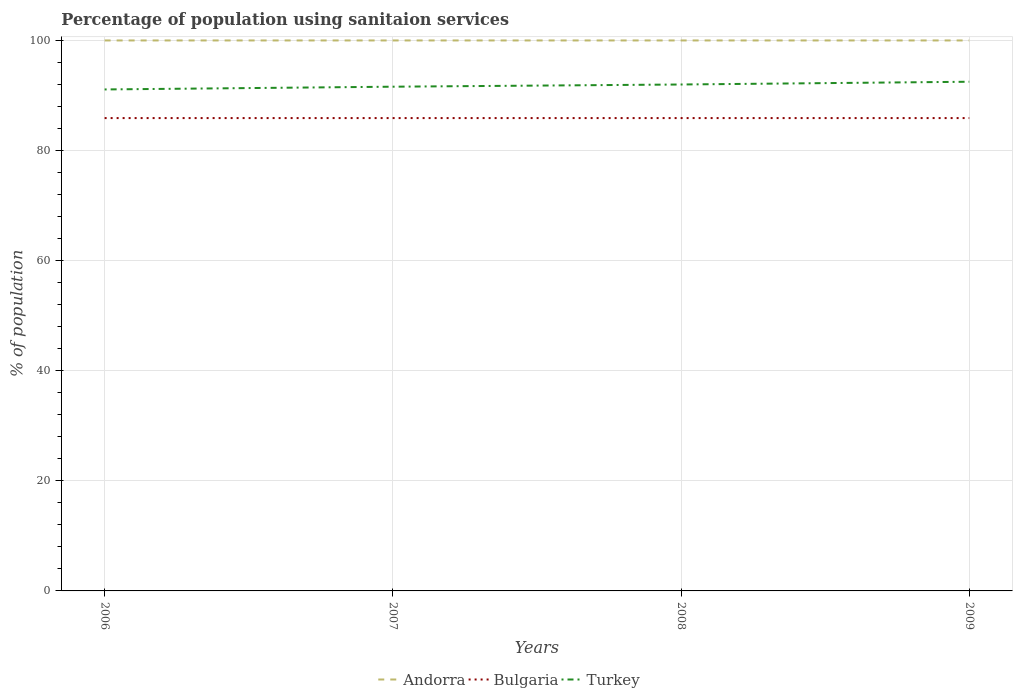How many different coloured lines are there?
Provide a succinct answer. 3. Across all years, what is the maximum percentage of population using sanitaion services in Turkey?
Offer a terse response. 91.1. In which year was the percentage of population using sanitaion services in Andorra maximum?
Your response must be concise. 2006. What is the total percentage of population using sanitaion services in Turkey in the graph?
Keep it short and to the point. -1.4. What is the difference between the highest and the second highest percentage of population using sanitaion services in Turkey?
Make the answer very short. 1.4. Is the percentage of population using sanitaion services in Turkey strictly greater than the percentage of population using sanitaion services in Bulgaria over the years?
Offer a terse response. No. How many lines are there?
Your answer should be very brief. 3. How many years are there in the graph?
Provide a succinct answer. 4. What is the difference between two consecutive major ticks on the Y-axis?
Ensure brevity in your answer.  20. What is the title of the graph?
Offer a terse response. Percentage of population using sanitaion services. What is the label or title of the X-axis?
Your answer should be compact. Years. What is the label or title of the Y-axis?
Your answer should be very brief. % of population. What is the % of population in Andorra in 2006?
Offer a terse response. 100. What is the % of population of Bulgaria in 2006?
Provide a succinct answer. 85.9. What is the % of population in Turkey in 2006?
Ensure brevity in your answer.  91.1. What is the % of population in Andorra in 2007?
Ensure brevity in your answer.  100. What is the % of population of Bulgaria in 2007?
Your response must be concise. 85.9. What is the % of population of Turkey in 2007?
Your answer should be very brief. 91.6. What is the % of population in Andorra in 2008?
Offer a very short reply. 100. What is the % of population of Bulgaria in 2008?
Make the answer very short. 85.9. What is the % of population in Turkey in 2008?
Your answer should be very brief. 92. What is the % of population in Andorra in 2009?
Ensure brevity in your answer.  100. What is the % of population in Bulgaria in 2009?
Your answer should be very brief. 85.9. What is the % of population of Turkey in 2009?
Your answer should be compact. 92.5. Across all years, what is the maximum % of population in Andorra?
Your response must be concise. 100. Across all years, what is the maximum % of population in Bulgaria?
Provide a short and direct response. 85.9. Across all years, what is the maximum % of population of Turkey?
Keep it short and to the point. 92.5. Across all years, what is the minimum % of population in Andorra?
Your answer should be very brief. 100. Across all years, what is the minimum % of population of Bulgaria?
Your answer should be very brief. 85.9. Across all years, what is the minimum % of population of Turkey?
Offer a very short reply. 91.1. What is the total % of population in Bulgaria in the graph?
Ensure brevity in your answer.  343.6. What is the total % of population of Turkey in the graph?
Provide a succinct answer. 367.2. What is the difference between the % of population of Bulgaria in 2006 and that in 2007?
Make the answer very short. 0. What is the difference between the % of population in Turkey in 2006 and that in 2007?
Your answer should be compact. -0.5. What is the difference between the % of population in Andorra in 2006 and that in 2008?
Make the answer very short. 0. What is the difference between the % of population of Bulgaria in 2006 and that in 2008?
Provide a short and direct response. 0. What is the difference between the % of population in Turkey in 2006 and that in 2009?
Your answer should be very brief. -1.4. What is the difference between the % of population in Bulgaria in 2007 and that in 2008?
Ensure brevity in your answer.  0. What is the difference between the % of population in Andorra in 2007 and that in 2009?
Provide a succinct answer. 0. What is the difference between the % of population in Bulgaria in 2007 and that in 2009?
Keep it short and to the point. 0. What is the difference between the % of population of Turkey in 2008 and that in 2009?
Make the answer very short. -0.5. What is the difference between the % of population of Andorra in 2006 and the % of population of Bulgaria in 2007?
Your answer should be compact. 14.1. What is the difference between the % of population of Andorra in 2006 and the % of population of Turkey in 2007?
Offer a very short reply. 8.4. What is the difference between the % of population in Bulgaria in 2006 and the % of population in Turkey in 2007?
Offer a very short reply. -5.7. What is the difference between the % of population in Andorra in 2006 and the % of population in Turkey in 2008?
Offer a very short reply. 8. What is the difference between the % of population of Andorra in 2006 and the % of population of Turkey in 2009?
Offer a very short reply. 7.5. What is the difference between the % of population in Andorra in 2007 and the % of population in Turkey in 2008?
Provide a short and direct response. 8. What is the difference between the % of population of Bulgaria in 2007 and the % of population of Turkey in 2008?
Make the answer very short. -6.1. What is the difference between the % of population in Andorra in 2007 and the % of population in Bulgaria in 2009?
Make the answer very short. 14.1. What is the average % of population in Bulgaria per year?
Offer a very short reply. 85.9. What is the average % of population in Turkey per year?
Your answer should be compact. 91.8. In the year 2006, what is the difference between the % of population in Andorra and % of population in Turkey?
Make the answer very short. 8.9. In the year 2006, what is the difference between the % of population of Bulgaria and % of population of Turkey?
Provide a short and direct response. -5.2. In the year 2007, what is the difference between the % of population in Bulgaria and % of population in Turkey?
Provide a succinct answer. -5.7. What is the ratio of the % of population in Andorra in 2006 to that in 2007?
Provide a short and direct response. 1. What is the ratio of the % of population of Turkey in 2006 to that in 2007?
Your answer should be compact. 0.99. What is the ratio of the % of population in Andorra in 2006 to that in 2008?
Your answer should be compact. 1. What is the ratio of the % of population of Bulgaria in 2006 to that in 2008?
Your answer should be very brief. 1. What is the ratio of the % of population in Turkey in 2006 to that in 2008?
Offer a terse response. 0.99. What is the ratio of the % of population of Andorra in 2006 to that in 2009?
Provide a short and direct response. 1. What is the ratio of the % of population in Turkey in 2006 to that in 2009?
Ensure brevity in your answer.  0.98. What is the ratio of the % of population in Turkey in 2007 to that in 2008?
Keep it short and to the point. 1. What is the ratio of the % of population of Bulgaria in 2007 to that in 2009?
Offer a terse response. 1. What is the ratio of the % of population of Turkey in 2007 to that in 2009?
Offer a terse response. 0.99. What is the ratio of the % of population of Turkey in 2008 to that in 2009?
Give a very brief answer. 0.99. What is the difference between the highest and the second highest % of population of Bulgaria?
Your answer should be very brief. 0. What is the difference between the highest and the second highest % of population in Turkey?
Ensure brevity in your answer.  0.5. What is the difference between the highest and the lowest % of population of Bulgaria?
Your response must be concise. 0. What is the difference between the highest and the lowest % of population in Turkey?
Provide a short and direct response. 1.4. 